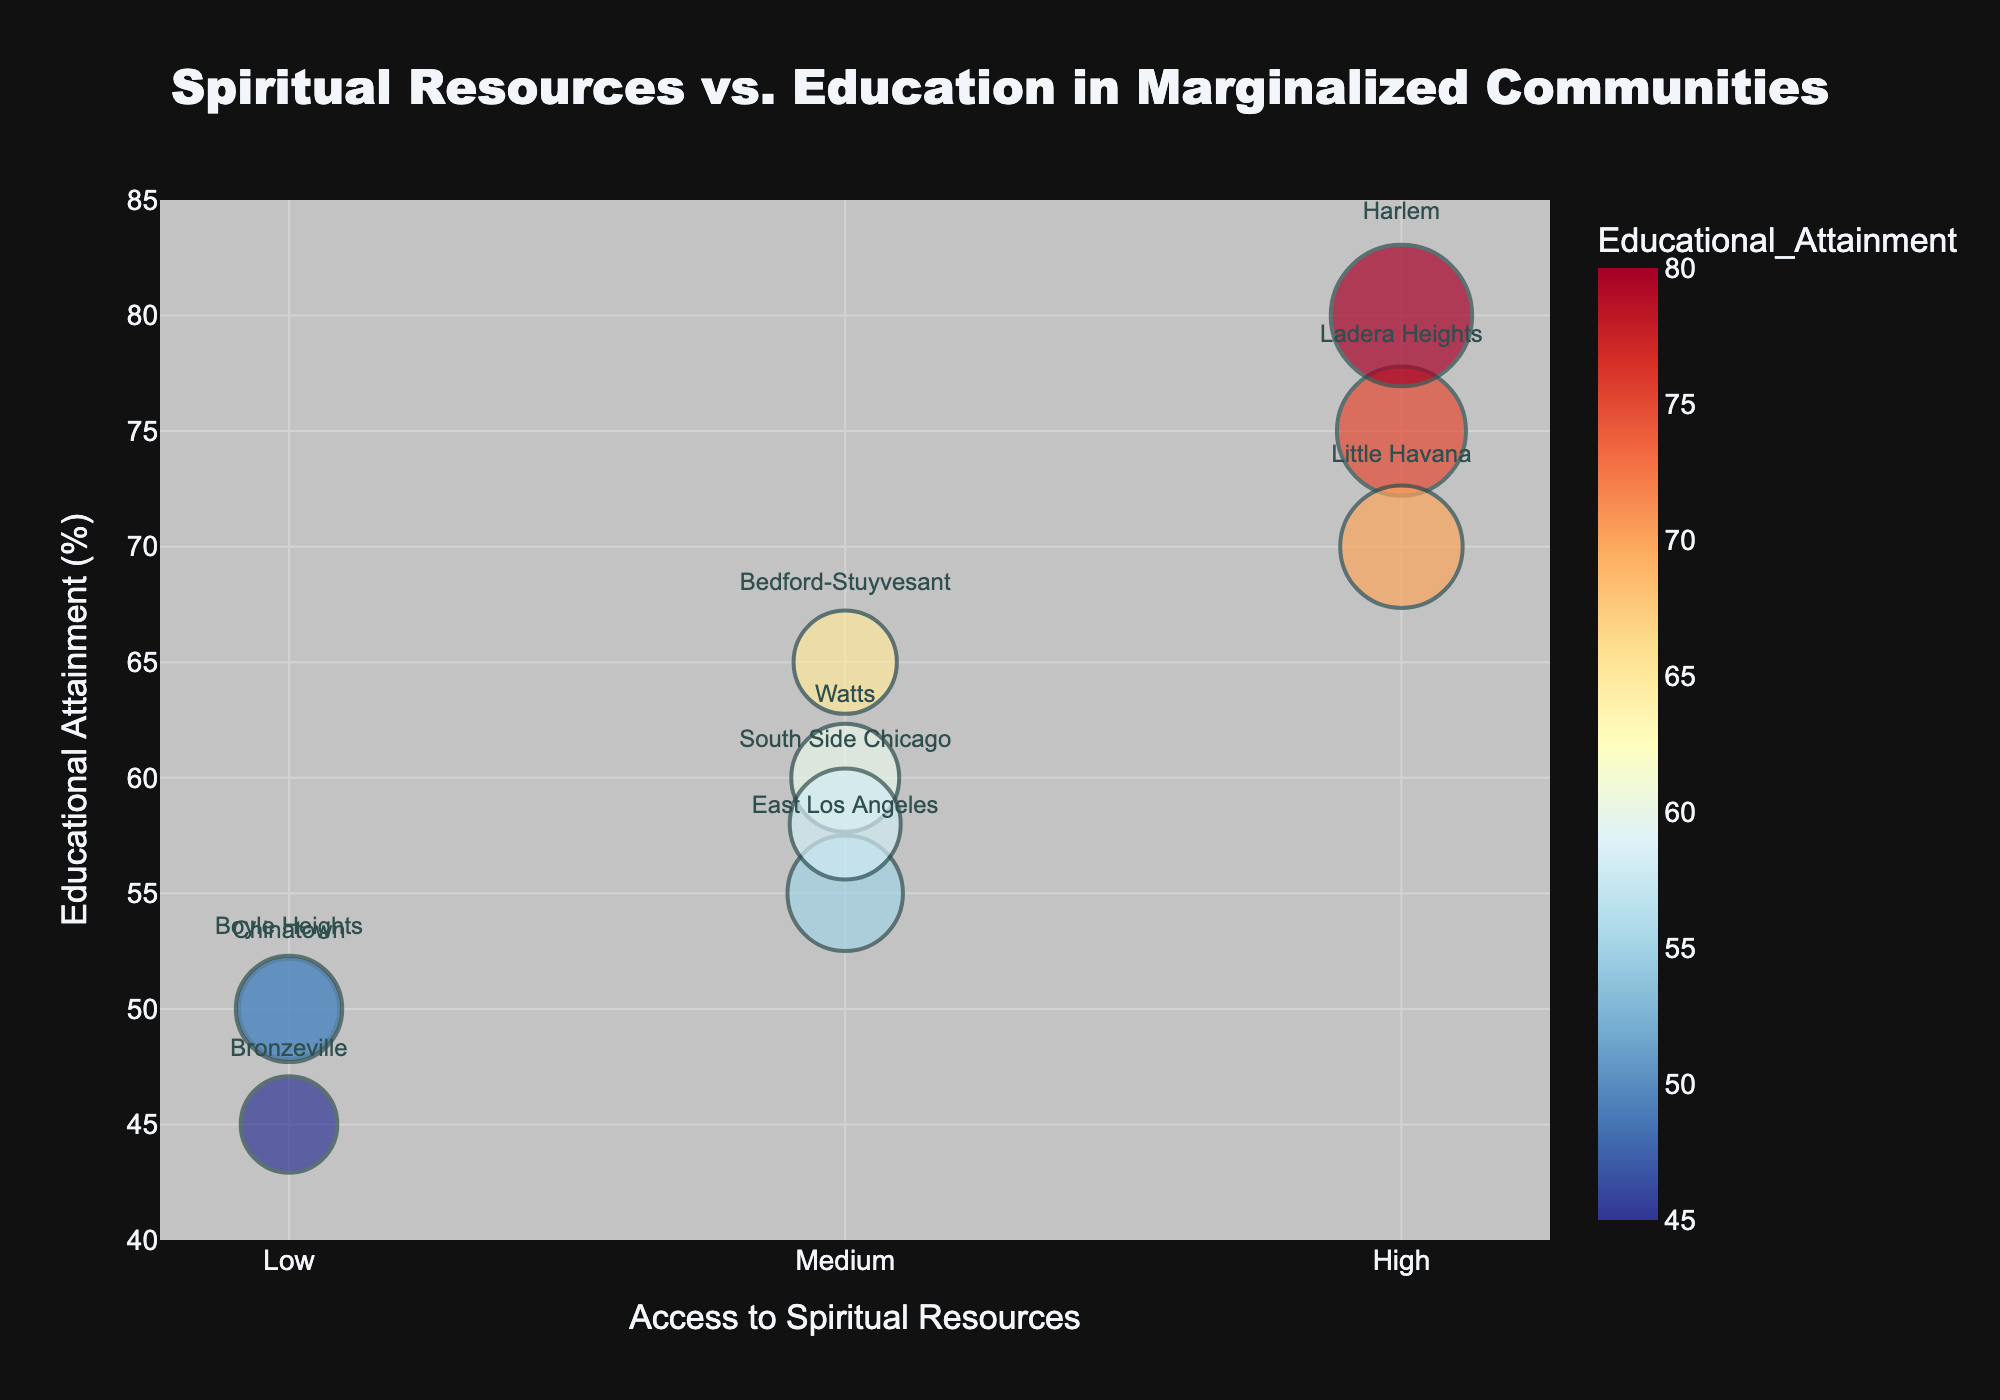How many communities have high access to spiritual resources? Look at the bubbles positioned along the x-axis labeled "High". Count how many bubbles are there.
Answer: 3 Which community has the highest educational attainment and what is its population size? Find the bubble that is highest on the y-axis. Check the label and the bubble size, which represents the population size.
Answer: Harlem, 6000 Compare the educational attainment between communities with medium access to spiritual resources. Identify all bubbles along the "Medium" x-axis. Compare their y-axis values to find the educational attainment for each.
Answer: Watts (60), East Los Angeles (55), Bedford-Stuyvesant (65), South Side Chicago (58) Which community with low access to spiritual resources has a higher educational attainment, Chinatown or Bronzeville? Look at the bubbles under the "Low" x-axis label, focusing on Chinatown and Bronzeville, then compare their y-axis values.
Answer: Chinatown What is the range of educational attainment for communities with medium access to spiritual resources? Identify the y-axis values for all medium access communities (Watts, East Los Angeles, Bedford-Stuyvesant, South Side Chicago). Calculate the difference between the highest and lowest values.
Answer: 65 - 55 = 10 Are there any communities with a lower educational attainment than South Side Chicago but a higher population size? Look for communities with a y-axis value less than 58 (South Side Chicago) and compare their size values (bubble size).
Answer: Chinatown, Boyle Heights Which community with high access to spiritual resources has the lowest educational attainment? Look at the bubbles under the "High" x-axis label and compare their y-axis values. Identify the community with the lowest y-axis value.
Answer: Little Havana What is the average educational attainment for communities with low access to spiritual resources? Identify the y-axis values for communities under "Low" access (Chinatown, Bronzeville, Boyle Heights). Calculate their average. (50 + 45 + 50) / 3
Answer: 48.33 Which communities have both a population size less than 3500 and medium access to spiritual resources? Identify communities under "Medium" access and check their bubble sizes to find those smaller than 3500.
Answer: Bedford-Stuyvesant How does the educational attainment of communities with low access to spiritual resources compare to those with high access? Identify y-axis values for both low access (Chinatown, Bronzeville, Boyle Heights) and high access (Ladera Heights, Harlem, Little Havana). Compare the overall trends and specific values.
Answer: High access communities generally have higher educational attainment 